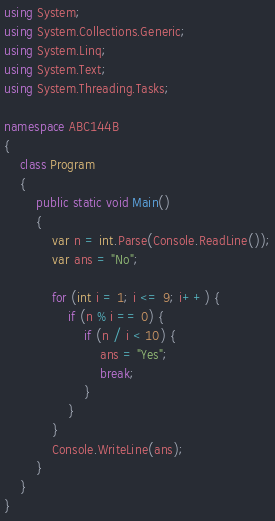Convert code to text. <code><loc_0><loc_0><loc_500><loc_500><_C#_>using System;
using System.Collections.Generic;
using System.Linq;
using System.Text;
using System.Threading.Tasks;

namespace ABC144B
{
    class Program
    {
        public static void Main()
        {
            var n = int.Parse(Console.ReadLine());
            var ans = "No";

            for (int i = 1; i <= 9; i++) {
                if (n % i == 0) {
                    if (n / i < 10) {
                        ans = "Yes";
                        break;
                    }
                }
            }
            Console.WriteLine(ans);
        }
    }
}
</code> 